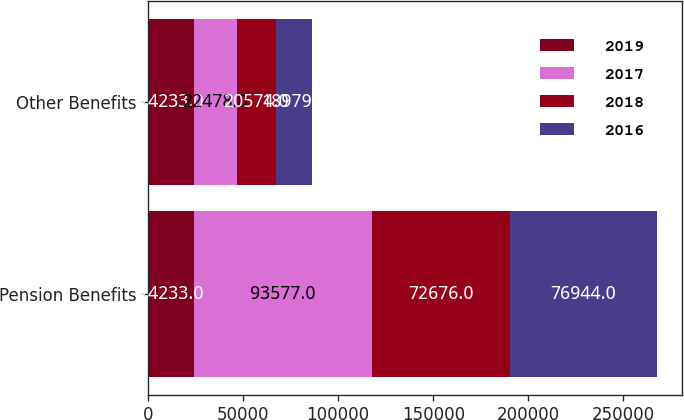Convert chart. <chart><loc_0><loc_0><loc_500><loc_500><stacked_bar_chart><ecel><fcel>Pension Benefits<fcel>Other Benefits<nl><fcel>2019<fcel>24233<fcel>24233<nl><fcel>2017<fcel>93577<fcel>22478<nl><fcel>2018<fcel>72676<fcel>20574<nl><fcel>2016<fcel>76944<fcel>18979<nl></chart> 